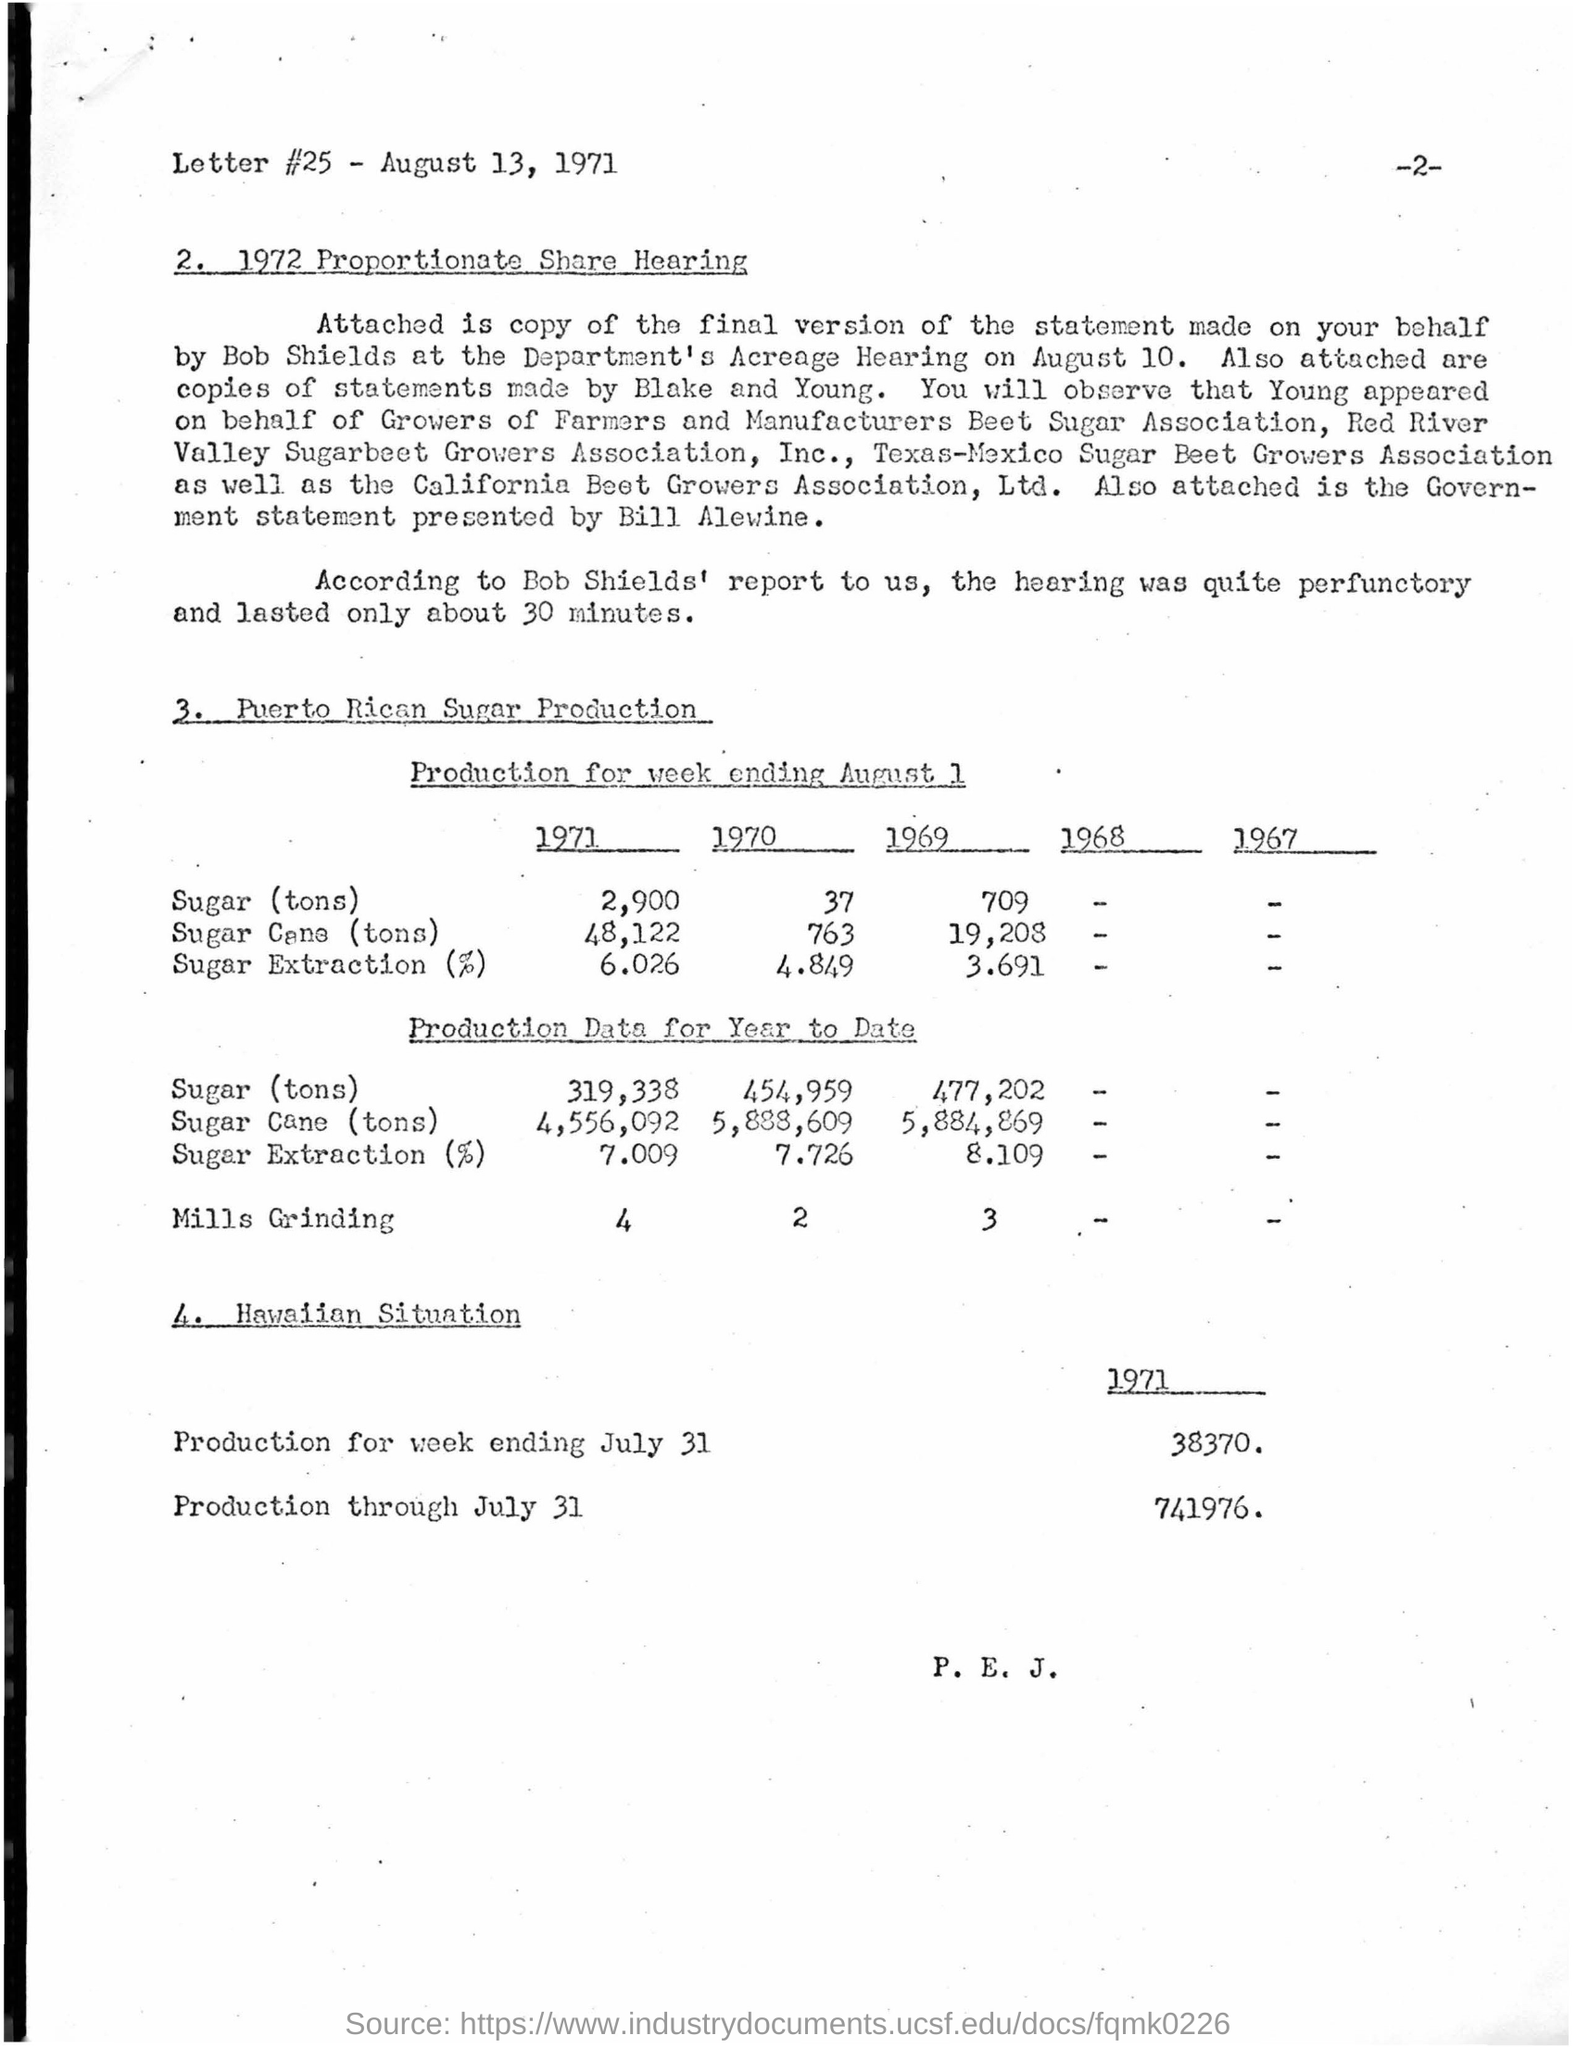Outline some significant characteristics in this image. According to Bob Shields' report, the hearing lasted for approximately 30 minutes. The production for the week ending JULY 31 in the year 1971 under the Hawaiian situation was 38,370. The "Proportionate Share Hearing" occurred in 1972. The quantity of sugar extracted as a percentage in the year 1970 was 4.849... The "Production Data for Year to Date" for "Mills Grinding" in the year 1971 was 4. 